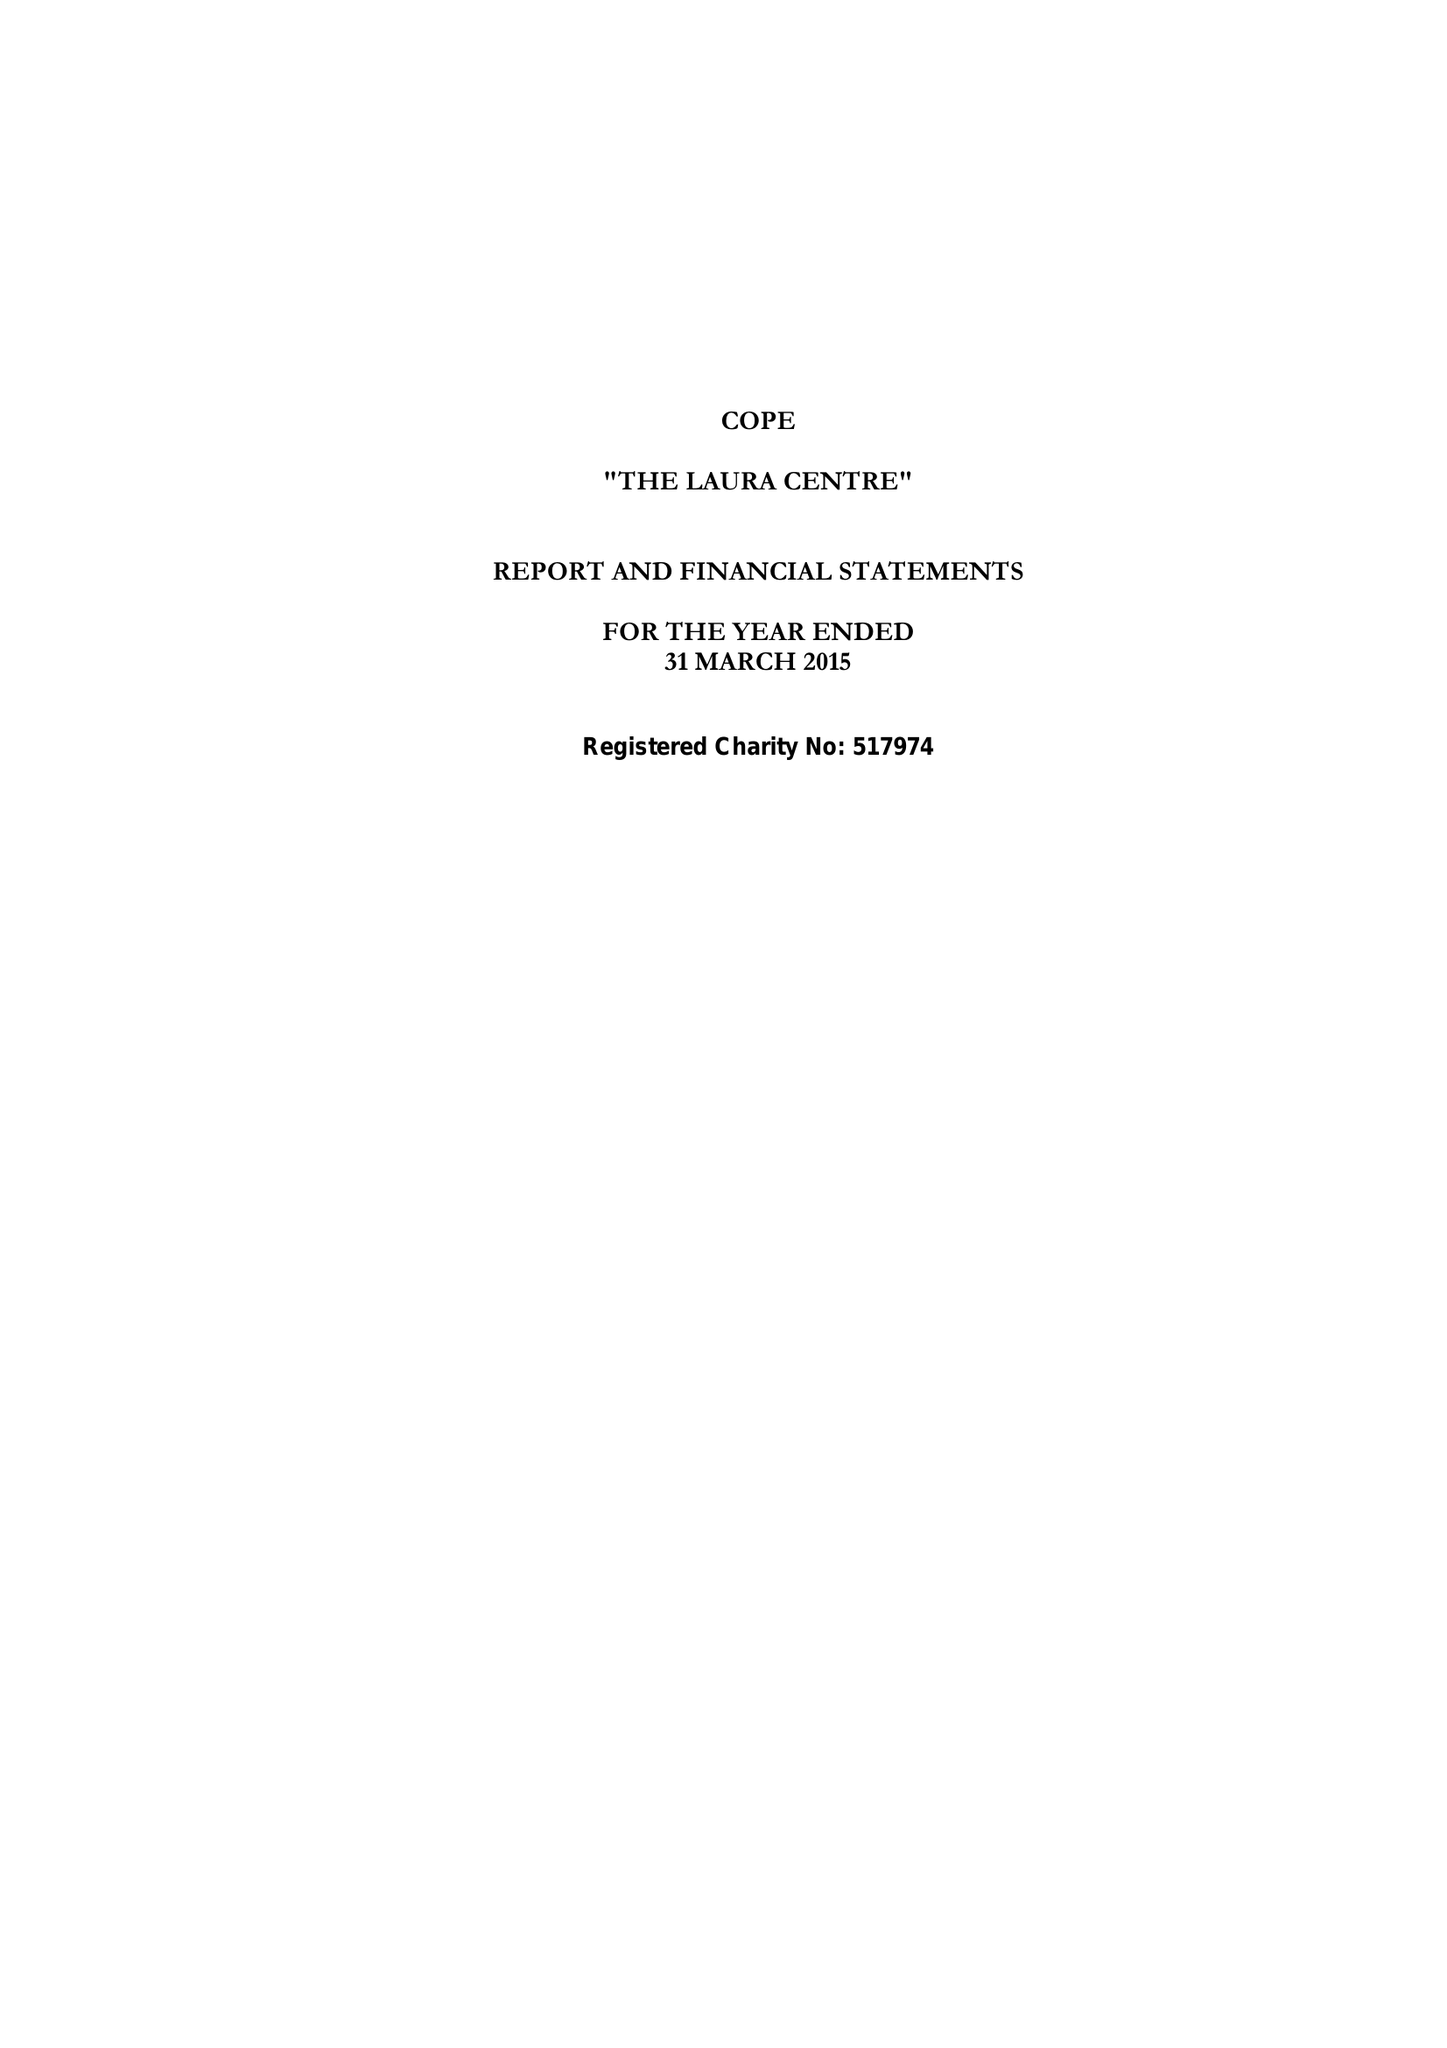What is the value for the income_annually_in_british_pounds?
Answer the question using a single word or phrase. 526803.00 